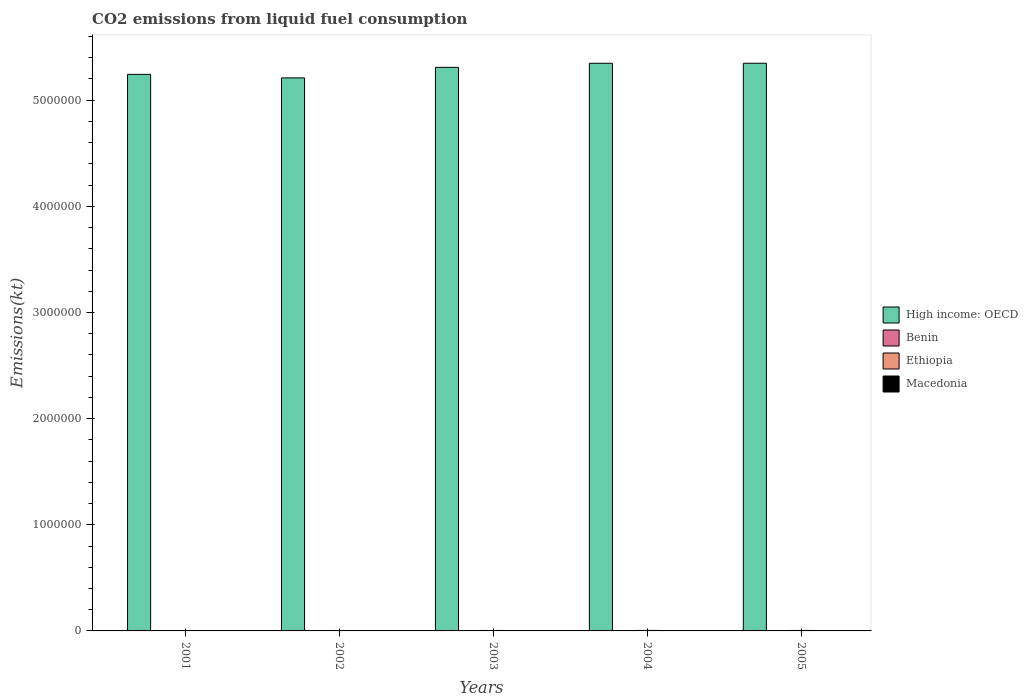How many groups of bars are there?
Provide a succinct answer. 5. Are the number of bars per tick equal to the number of legend labels?
Ensure brevity in your answer.  Yes. How many bars are there on the 3rd tick from the left?
Offer a terse response. 4. What is the label of the 5th group of bars from the left?
Give a very brief answer. 2005. In how many cases, is the number of bars for a given year not equal to the number of legend labels?
Make the answer very short. 0. What is the amount of CO2 emitted in Ethiopia in 2002?
Keep it short and to the point. 4033.7. Across all years, what is the maximum amount of CO2 emitted in Macedonia?
Make the answer very short. 2684.24. Across all years, what is the minimum amount of CO2 emitted in Benin?
Keep it short and to the point. 1690.49. In which year was the amount of CO2 emitted in Benin minimum?
Offer a terse response. 2001. What is the total amount of CO2 emitted in Ethiopia in the graph?
Your answer should be very brief. 2.11e+04. What is the difference between the amount of CO2 emitted in Macedonia in 2003 and that in 2005?
Give a very brief answer. -154.01. What is the difference between the amount of CO2 emitted in High income: OECD in 2005 and the amount of CO2 emitted in Ethiopia in 2003?
Your response must be concise. 5.34e+06. What is the average amount of CO2 emitted in Ethiopia per year?
Offer a terse response. 4227.32. In the year 2004, what is the difference between the amount of CO2 emitted in Benin and amount of CO2 emitted in Macedonia?
Keep it short and to the point. -216.35. In how many years, is the amount of CO2 emitted in High income: OECD greater than 5200000 kt?
Your response must be concise. 5. What is the ratio of the amount of CO2 emitted in Benin in 2002 to that in 2005?
Make the answer very short. 0.86. Is the difference between the amount of CO2 emitted in Benin in 2004 and 2005 greater than the difference between the amount of CO2 emitted in Macedonia in 2004 and 2005?
Your answer should be compact. Yes. What is the difference between the highest and the second highest amount of CO2 emitted in Ethiopia?
Your answer should be compact. 205.35. What is the difference between the highest and the lowest amount of CO2 emitted in Ethiopia?
Offer a very short reply. 726.07. What does the 3rd bar from the left in 2001 represents?
Keep it short and to the point. Ethiopia. What does the 3rd bar from the right in 2005 represents?
Your response must be concise. Benin. Is it the case that in every year, the sum of the amount of CO2 emitted in Ethiopia and amount of CO2 emitted in High income: OECD is greater than the amount of CO2 emitted in Macedonia?
Give a very brief answer. Yes. Are all the bars in the graph horizontal?
Your response must be concise. No. How many years are there in the graph?
Provide a short and direct response. 5. Does the graph contain grids?
Your answer should be very brief. No. How are the legend labels stacked?
Offer a terse response. Vertical. What is the title of the graph?
Keep it short and to the point. CO2 emissions from liquid fuel consumption. What is the label or title of the X-axis?
Make the answer very short. Years. What is the label or title of the Y-axis?
Your answer should be very brief. Emissions(kt). What is the Emissions(kt) in High income: OECD in 2001?
Provide a short and direct response. 5.24e+06. What is the Emissions(kt) in Benin in 2001?
Provide a succinct answer. 1690.49. What is the Emissions(kt) of Ethiopia in 2001?
Provide a succinct answer. 3861.35. What is the Emissions(kt) in Macedonia in 2001?
Give a very brief answer. 2299.21. What is the Emissions(kt) of High income: OECD in 2002?
Offer a terse response. 5.21e+06. What is the Emissions(kt) of Benin in 2002?
Provide a short and direct response. 1954.51. What is the Emissions(kt) of Ethiopia in 2002?
Your answer should be compact. 4033.7. What is the Emissions(kt) in Macedonia in 2002?
Keep it short and to the point. 2563.23. What is the Emissions(kt) in High income: OECD in 2003?
Ensure brevity in your answer.  5.31e+06. What is the Emissions(kt) in Benin in 2003?
Your response must be concise. 2229.54. What is the Emissions(kt) in Ethiopia in 2003?
Provide a succinct answer. 4382.06. What is the Emissions(kt) in Macedonia in 2003?
Ensure brevity in your answer.  2530.23. What is the Emissions(kt) in High income: OECD in 2004?
Your response must be concise. 5.35e+06. What is the Emissions(kt) of Benin in 2004?
Provide a succinct answer. 2383.55. What is the Emissions(kt) of Ethiopia in 2004?
Keep it short and to the point. 4587.42. What is the Emissions(kt) in Macedonia in 2004?
Your answer should be very brief. 2599.9. What is the Emissions(kt) of High income: OECD in 2005?
Your answer should be compact. 5.35e+06. What is the Emissions(kt) of Benin in 2005?
Your response must be concise. 2269.87. What is the Emissions(kt) in Ethiopia in 2005?
Ensure brevity in your answer.  4272.06. What is the Emissions(kt) of Macedonia in 2005?
Keep it short and to the point. 2684.24. Across all years, what is the maximum Emissions(kt) of High income: OECD?
Make the answer very short. 5.35e+06. Across all years, what is the maximum Emissions(kt) in Benin?
Keep it short and to the point. 2383.55. Across all years, what is the maximum Emissions(kt) of Ethiopia?
Your response must be concise. 4587.42. Across all years, what is the maximum Emissions(kt) of Macedonia?
Your response must be concise. 2684.24. Across all years, what is the minimum Emissions(kt) of High income: OECD?
Give a very brief answer. 5.21e+06. Across all years, what is the minimum Emissions(kt) in Benin?
Your answer should be very brief. 1690.49. Across all years, what is the minimum Emissions(kt) of Ethiopia?
Give a very brief answer. 3861.35. Across all years, what is the minimum Emissions(kt) of Macedonia?
Your answer should be very brief. 2299.21. What is the total Emissions(kt) of High income: OECD in the graph?
Ensure brevity in your answer.  2.65e+07. What is the total Emissions(kt) of Benin in the graph?
Your response must be concise. 1.05e+04. What is the total Emissions(kt) in Ethiopia in the graph?
Keep it short and to the point. 2.11e+04. What is the total Emissions(kt) in Macedonia in the graph?
Your answer should be compact. 1.27e+04. What is the difference between the Emissions(kt) of High income: OECD in 2001 and that in 2002?
Your response must be concise. 3.33e+04. What is the difference between the Emissions(kt) of Benin in 2001 and that in 2002?
Keep it short and to the point. -264.02. What is the difference between the Emissions(kt) of Ethiopia in 2001 and that in 2002?
Offer a very short reply. -172.35. What is the difference between the Emissions(kt) in Macedonia in 2001 and that in 2002?
Ensure brevity in your answer.  -264.02. What is the difference between the Emissions(kt) in High income: OECD in 2001 and that in 2003?
Your response must be concise. -6.61e+04. What is the difference between the Emissions(kt) in Benin in 2001 and that in 2003?
Ensure brevity in your answer.  -539.05. What is the difference between the Emissions(kt) of Ethiopia in 2001 and that in 2003?
Provide a short and direct response. -520.71. What is the difference between the Emissions(kt) of Macedonia in 2001 and that in 2003?
Provide a short and direct response. -231.02. What is the difference between the Emissions(kt) of High income: OECD in 2001 and that in 2004?
Make the answer very short. -1.04e+05. What is the difference between the Emissions(kt) in Benin in 2001 and that in 2004?
Offer a very short reply. -693.06. What is the difference between the Emissions(kt) in Ethiopia in 2001 and that in 2004?
Give a very brief answer. -726.07. What is the difference between the Emissions(kt) of Macedonia in 2001 and that in 2004?
Offer a very short reply. -300.69. What is the difference between the Emissions(kt) of High income: OECD in 2001 and that in 2005?
Ensure brevity in your answer.  -1.05e+05. What is the difference between the Emissions(kt) in Benin in 2001 and that in 2005?
Offer a terse response. -579.39. What is the difference between the Emissions(kt) of Ethiopia in 2001 and that in 2005?
Provide a short and direct response. -410.7. What is the difference between the Emissions(kt) in Macedonia in 2001 and that in 2005?
Provide a short and direct response. -385.04. What is the difference between the Emissions(kt) in High income: OECD in 2002 and that in 2003?
Your answer should be compact. -9.93e+04. What is the difference between the Emissions(kt) of Benin in 2002 and that in 2003?
Offer a very short reply. -275.02. What is the difference between the Emissions(kt) of Ethiopia in 2002 and that in 2003?
Offer a terse response. -348.37. What is the difference between the Emissions(kt) of Macedonia in 2002 and that in 2003?
Your answer should be very brief. 33. What is the difference between the Emissions(kt) in High income: OECD in 2002 and that in 2004?
Provide a short and direct response. -1.37e+05. What is the difference between the Emissions(kt) in Benin in 2002 and that in 2004?
Provide a short and direct response. -429.04. What is the difference between the Emissions(kt) in Ethiopia in 2002 and that in 2004?
Offer a terse response. -553.72. What is the difference between the Emissions(kt) in Macedonia in 2002 and that in 2004?
Keep it short and to the point. -36.67. What is the difference between the Emissions(kt) in High income: OECD in 2002 and that in 2005?
Ensure brevity in your answer.  -1.38e+05. What is the difference between the Emissions(kt) of Benin in 2002 and that in 2005?
Provide a short and direct response. -315.36. What is the difference between the Emissions(kt) in Ethiopia in 2002 and that in 2005?
Make the answer very short. -238.35. What is the difference between the Emissions(kt) of Macedonia in 2002 and that in 2005?
Keep it short and to the point. -121.01. What is the difference between the Emissions(kt) of High income: OECD in 2003 and that in 2004?
Provide a short and direct response. -3.81e+04. What is the difference between the Emissions(kt) in Benin in 2003 and that in 2004?
Offer a very short reply. -154.01. What is the difference between the Emissions(kt) of Ethiopia in 2003 and that in 2004?
Your response must be concise. -205.35. What is the difference between the Emissions(kt) of Macedonia in 2003 and that in 2004?
Offer a very short reply. -69.67. What is the difference between the Emissions(kt) in High income: OECD in 2003 and that in 2005?
Offer a very short reply. -3.84e+04. What is the difference between the Emissions(kt) of Benin in 2003 and that in 2005?
Make the answer very short. -40.34. What is the difference between the Emissions(kt) in Ethiopia in 2003 and that in 2005?
Your answer should be compact. 110.01. What is the difference between the Emissions(kt) in Macedonia in 2003 and that in 2005?
Keep it short and to the point. -154.01. What is the difference between the Emissions(kt) in High income: OECD in 2004 and that in 2005?
Provide a succinct answer. -322.7. What is the difference between the Emissions(kt) of Benin in 2004 and that in 2005?
Ensure brevity in your answer.  113.68. What is the difference between the Emissions(kt) in Ethiopia in 2004 and that in 2005?
Keep it short and to the point. 315.36. What is the difference between the Emissions(kt) of Macedonia in 2004 and that in 2005?
Provide a succinct answer. -84.34. What is the difference between the Emissions(kt) of High income: OECD in 2001 and the Emissions(kt) of Benin in 2002?
Your response must be concise. 5.24e+06. What is the difference between the Emissions(kt) of High income: OECD in 2001 and the Emissions(kt) of Ethiopia in 2002?
Keep it short and to the point. 5.24e+06. What is the difference between the Emissions(kt) in High income: OECD in 2001 and the Emissions(kt) in Macedonia in 2002?
Your answer should be very brief. 5.24e+06. What is the difference between the Emissions(kt) in Benin in 2001 and the Emissions(kt) in Ethiopia in 2002?
Your answer should be compact. -2343.21. What is the difference between the Emissions(kt) in Benin in 2001 and the Emissions(kt) in Macedonia in 2002?
Your response must be concise. -872.75. What is the difference between the Emissions(kt) in Ethiopia in 2001 and the Emissions(kt) in Macedonia in 2002?
Give a very brief answer. 1298.12. What is the difference between the Emissions(kt) in High income: OECD in 2001 and the Emissions(kt) in Benin in 2003?
Ensure brevity in your answer.  5.24e+06. What is the difference between the Emissions(kt) of High income: OECD in 2001 and the Emissions(kt) of Ethiopia in 2003?
Give a very brief answer. 5.24e+06. What is the difference between the Emissions(kt) of High income: OECD in 2001 and the Emissions(kt) of Macedonia in 2003?
Offer a terse response. 5.24e+06. What is the difference between the Emissions(kt) in Benin in 2001 and the Emissions(kt) in Ethiopia in 2003?
Offer a very short reply. -2691.58. What is the difference between the Emissions(kt) of Benin in 2001 and the Emissions(kt) of Macedonia in 2003?
Ensure brevity in your answer.  -839.74. What is the difference between the Emissions(kt) in Ethiopia in 2001 and the Emissions(kt) in Macedonia in 2003?
Your answer should be very brief. 1331.12. What is the difference between the Emissions(kt) of High income: OECD in 2001 and the Emissions(kt) of Benin in 2004?
Make the answer very short. 5.24e+06. What is the difference between the Emissions(kt) in High income: OECD in 2001 and the Emissions(kt) in Ethiopia in 2004?
Give a very brief answer. 5.24e+06. What is the difference between the Emissions(kt) of High income: OECD in 2001 and the Emissions(kt) of Macedonia in 2004?
Keep it short and to the point. 5.24e+06. What is the difference between the Emissions(kt) of Benin in 2001 and the Emissions(kt) of Ethiopia in 2004?
Keep it short and to the point. -2896.93. What is the difference between the Emissions(kt) in Benin in 2001 and the Emissions(kt) in Macedonia in 2004?
Your answer should be compact. -909.42. What is the difference between the Emissions(kt) of Ethiopia in 2001 and the Emissions(kt) of Macedonia in 2004?
Ensure brevity in your answer.  1261.45. What is the difference between the Emissions(kt) in High income: OECD in 2001 and the Emissions(kt) in Benin in 2005?
Ensure brevity in your answer.  5.24e+06. What is the difference between the Emissions(kt) of High income: OECD in 2001 and the Emissions(kt) of Ethiopia in 2005?
Offer a terse response. 5.24e+06. What is the difference between the Emissions(kt) of High income: OECD in 2001 and the Emissions(kt) of Macedonia in 2005?
Offer a terse response. 5.24e+06. What is the difference between the Emissions(kt) of Benin in 2001 and the Emissions(kt) of Ethiopia in 2005?
Offer a terse response. -2581.57. What is the difference between the Emissions(kt) of Benin in 2001 and the Emissions(kt) of Macedonia in 2005?
Provide a succinct answer. -993.76. What is the difference between the Emissions(kt) of Ethiopia in 2001 and the Emissions(kt) of Macedonia in 2005?
Make the answer very short. 1177.11. What is the difference between the Emissions(kt) of High income: OECD in 2002 and the Emissions(kt) of Benin in 2003?
Your answer should be compact. 5.21e+06. What is the difference between the Emissions(kt) in High income: OECD in 2002 and the Emissions(kt) in Ethiopia in 2003?
Keep it short and to the point. 5.21e+06. What is the difference between the Emissions(kt) in High income: OECD in 2002 and the Emissions(kt) in Macedonia in 2003?
Keep it short and to the point. 5.21e+06. What is the difference between the Emissions(kt) of Benin in 2002 and the Emissions(kt) of Ethiopia in 2003?
Make the answer very short. -2427.55. What is the difference between the Emissions(kt) in Benin in 2002 and the Emissions(kt) in Macedonia in 2003?
Offer a very short reply. -575.72. What is the difference between the Emissions(kt) in Ethiopia in 2002 and the Emissions(kt) in Macedonia in 2003?
Offer a terse response. 1503.47. What is the difference between the Emissions(kt) of High income: OECD in 2002 and the Emissions(kt) of Benin in 2004?
Make the answer very short. 5.21e+06. What is the difference between the Emissions(kt) of High income: OECD in 2002 and the Emissions(kt) of Ethiopia in 2004?
Make the answer very short. 5.21e+06. What is the difference between the Emissions(kt) in High income: OECD in 2002 and the Emissions(kt) in Macedonia in 2004?
Provide a short and direct response. 5.21e+06. What is the difference between the Emissions(kt) of Benin in 2002 and the Emissions(kt) of Ethiopia in 2004?
Keep it short and to the point. -2632.91. What is the difference between the Emissions(kt) of Benin in 2002 and the Emissions(kt) of Macedonia in 2004?
Provide a succinct answer. -645.39. What is the difference between the Emissions(kt) in Ethiopia in 2002 and the Emissions(kt) in Macedonia in 2004?
Your answer should be very brief. 1433.8. What is the difference between the Emissions(kt) in High income: OECD in 2002 and the Emissions(kt) in Benin in 2005?
Give a very brief answer. 5.21e+06. What is the difference between the Emissions(kt) of High income: OECD in 2002 and the Emissions(kt) of Ethiopia in 2005?
Ensure brevity in your answer.  5.21e+06. What is the difference between the Emissions(kt) of High income: OECD in 2002 and the Emissions(kt) of Macedonia in 2005?
Provide a succinct answer. 5.21e+06. What is the difference between the Emissions(kt) in Benin in 2002 and the Emissions(kt) in Ethiopia in 2005?
Give a very brief answer. -2317.54. What is the difference between the Emissions(kt) of Benin in 2002 and the Emissions(kt) of Macedonia in 2005?
Your response must be concise. -729.73. What is the difference between the Emissions(kt) of Ethiopia in 2002 and the Emissions(kt) of Macedonia in 2005?
Your response must be concise. 1349.46. What is the difference between the Emissions(kt) in High income: OECD in 2003 and the Emissions(kt) in Benin in 2004?
Give a very brief answer. 5.31e+06. What is the difference between the Emissions(kt) in High income: OECD in 2003 and the Emissions(kt) in Ethiopia in 2004?
Make the answer very short. 5.30e+06. What is the difference between the Emissions(kt) of High income: OECD in 2003 and the Emissions(kt) of Macedonia in 2004?
Ensure brevity in your answer.  5.31e+06. What is the difference between the Emissions(kt) of Benin in 2003 and the Emissions(kt) of Ethiopia in 2004?
Give a very brief answer. -2357.88. What is the difference between the Emissions(kt) in Benin in 2003 and the Emissions(kt) in Macedonia in 2004?
Offer a terse response. -370.37. What is the difference between the Emissions(kt) of Ethiopia in 2003 and the Emissions(kt) of Macedonia in 2004?
Your answer should be very brief. 1782.16. What is the difference between the Emissions(kt) of High income: OECD in 2003 and the Emissions(kt) of Benin in 2005?
Ensure brevity in your answer.  5.31e+06. What is the difference between the Emissions(kt) in High income: OECD in 2003 and the Emissions(kt) in Ethiopia in 2005?
Offer a terse response. 5.31e+06. What is the difference between the Emissions(kt) of High income: OECD in 2003 and the Emissions(kt) of Macedonia in 2005?
Your answer should be compact. 5.31e+06. What is the difference between the Emissions(kt) of Benin in 2003 and the Emissions(kt) of Ethiopia in 2005?
Your answer should be very brief. -2042.52. What is the difference between the Emissions(kt) of Benin in 2003 and the Emissions(kt) of Macedonia in 2005?
Provide a succinct answer. -454.71. What is the difference between the Emissions(kt) of Ethiopia in 2003 and the Emissions(kt) of Macedonia in 2005?
Your answer should be very brief. 1697.82. What is the difference between the Emissions(kt) in High income: OECD in 2004 and the Emissions(kt) in Benin in 2005?
Ensure brevity in your answer.  5.35e+06. What is the difference between the Emissions(kt) of High income: OECD in 2004 and the Emissions(kt) of Ethiopia in 2005?
Offer a terse response. 5.34e+06. What is the difference between the Emissions(kt) of High income: OECD in 2004 and the Emissions(kt) of Macedonia in 2005?
Your response must be concise. 5.34e+06. What is the difference between the Emissions(kt) in Benin in 2004 and the Emissions(kt) in Ethiopia in 2005?
Keep it short and to the point. -1888.51. What is the difference between the Emissions(kt) of Benin in 2004 and the Emissions(kt) of Macedonia in 2005?
Your response must be concise. -300.69. What is the difference between the Emissions(kt) of Ethiopia in 2004 and the Emissions(kt) of Macedonia in 2005?
Make the answer very short. 1903.17. What is the average Emissions(kt) in High income: OECD per year?
Provide a succinct answer. 5.29e+06. What is the average Emissions(kt) of Benin per year?
Keep it short and to the point. 2105.59. What is the average Emissions(kt) in Ethiopia per year?
Provide a short and direct response. 4227.32. What is the average Emissions(kt) in Macedonia per year?
Provide a short and direct response. 2535.36. In the year 2001, what is the difference between the Emissions(kt) in High income: OECD and Emissions(kt) in Benin?
Offer a terse response. 5.24e+06. In the year 2001, what is the difference between the Emissions(kt) of High income: OECD and Emissions(kt) of Ethiopia?
Offer a terse response. 5.24e+06. In the year 2001, what is the difference between the Emissions(kt) in High income: OECD and Emissions(kt) in Macedonia?
Give a very brief answer. 5.24e+06. In the year 2001, what is the difference between the Emissions(kt) in Benin and Emissions(kt) in Ethiopia?
Keep it short and to the point. -2170.86. In the year 2001, what is the difference between the Emissions(kt) in Benin and Emissions(kt) in Macedonia?
Offer a terse response. -608.72. In the year 2001, what is the difference between the Emissions(kt) of Ethiopia and Emissions(kt) of Macedonia?
Make the answer very short. 1562.14. In the year 2002, what is the difference between the Emissions(kt) of High income: OECD and Emissions(kt) of Benin?
Ensure brevity in your answer.  5.21e+06. In the year 2002, what is the difference between the Emissions(kt) of High income: OECD and Emissions(kt) of Ethiopia?
Offer a terse response. 5.21e+06. In the year 2002, what is the difference between the Emissions(kt) of High income: OECD and Emissions(kt) of Macedonia?
Offer a very short reply. 5.21e+06. In the year 2002, what is the difference between the Emissions(kt) of Benin and Emissions(kt) of Ethiopia?
Make the answer very short. -2079.19. In the year 2002, what is the difference between the Emissions(kt) of Benin and Emissions(kt) of Macedonia?
Give a very brief answer. -608.72. In the year 2002, what is the difference between the Emissions(kt) in Ethiopia and Emissions(kt) in Macedonia?
Offer a terse response. 1470.47. In the year 2003, what is the difference between the Emissions(kt) of High income: OECD and Emissions(kt) of Benin?
Your answer should be very brief. 5.31e+06. In the year 2003, what is the difference between the Emissions(kt) in High income: OECD and Emissions(kt) in Ethiopia?
Provide a succinct answer. 5.31e+06. In the year 2003, what is the difference between the Emissions(kt) of High income: OECD and Emissions(kt) of Macedonia?
Keep it short and to the point. 5.31e+06. In the year 2003, what is the difference between the Emissions(kt) in Benin and Emissions(kt) in Ethiopia?
Provide a succinct answer. -2152.53. In the year 2003, what is the difference between the Emissions(kt) of Benin and Emissions(kt) of Macedonia?
Keep it short and to the point. -300.69. In the year 2003, what is the difference between the Emissions(kt) of Ethiopia and Emissions(kt) of Macedonia?
Give a very brief answer. 1851.84. In the year 2004, what is the difference between the Emissions(kt) in High income: OECD and Emissions(kt) in Benin?
Make the answer very short. 5.35e+06. In the year 2004, what is the difference between the Emissions(kt) in High income: OECD and Emissions(kt) in Ethiopia?
Offer a terse response. 5.34e+06. In the year 2004, what is the difference between the Emissions(kt) in High income: OECD and Emissions(kt) in Macedonia?
Your answer should be very brief. 5.35e+06. In the year 2004, what is the difference between the Emissions(kt) of Benin and Emissions(kt) of Ethiopia?
Offer a very short reply. -2203.87. In the year 2004, what is the difference between the Emissions(kt) of Benin and Emissions(kt) of Macedonia?
Provide a short and direct response. -216.35. In the year 2004, what is the difference between the Emissions(kt) of Ethiopia and Emissions(kt) of Macedonia?
Offer a very short reply. 1987.51. In the year 2005, what is the difference between the Emissions(kt) of High income: OECD and Emissions(kt) of Benin?
Make the answer very short. 5.35e+06. In the year 2005, what is the difference between the Emissions(kt) in High income: OECD and Emissions(kt) in Ethiopia?
Provide a succinct answer. 5.34e+06. In the year 2005, what is the difference between the Emissions(kt) of High income: OECD and Emissions(kt) of Macedonia?
Provide a short and direct response. 5.35e+06. In the year 2005, what is the difference between the Emissions(kt) of Benin and Emissions(kt) of Ethiopia?
Your answer should be very brief. -2002.18. In the year 2005, what is the difference between the Emissions(kt) of Benin and Emissions(kt) of Macedonia?
Offer a very short reply. -414.37. In the year 2005, what is the difference between the Emissions(kt) in Ethiopia and Emissions(kt) in Macedonia?
Offer a terse response. 1587.81. What is the ratio of the Emissions(kt) in High income: OECD in 2001 to that in 2002?
Make the answer very short. 1.01. What is the ratio of the Emissions(kt) of Benin in 2001 to that in 2002?
Offer a very short reply. 0.86. What is the ratio of the Emissions(kt) of Ethiopia in 2001 to that in 2002?
Your response must be concise. 0.96. What is the ratio of the Emissions(kt) in Macedonia in 2001 to that in 2002?
Ensure brevity in your answer.  0.9. What is the ratio of the Emissions(kt) of High income: OECD in 2001 to that in 2003?
Provide a succinct answer. 0.99. What is the ratio of the Emissions(kt) in Benin in 2001 to that in 2003?
Give a very brief answer. 0.76. What is the ratio of the Emissions(kt) of Ethiopia in 2001 to that in 2003?
Give a very brief answer. 0.88. What is the ratio of the Emissions(kt) of Macedonia in 2001 to that in 2003?
Your response must be concise. 0.91. What is the ratio of the Emissions(kt) of High income: OECD in 2001 to that in 2004?
Make the answer very short. 0.98. What is the ratio of the Emissions(kt) in Benin in 2001 to that in 2004?
Your answer should be very brief. 0.71. What is the ratio of the Emissions(kt) in Ethiopia in 2001 to that in 2004?
Provide a succinct answer. 0.84. What is the ratio of the Emissions(kt) of Macedonia in 2001 to that in 2004?
Offer a terse response. 0.88. What is the ratio of the Emissions(kt) in High income: OECD in 2001 to that in 2005?
Your answer should be very brief. 0.98. What is the ratio of the Emissions(kt) of Benin in 2001 to that in 2005?
Your answer should be very brief. 0.74. What is the ratio of the Emissions(kt) in Ethiopia in 2001 to that in 2005?
Offer a terse response. 0.9. What is the ratio of the Emissions(kt) in Macedonia in 2001 to that in 2005?
Ensure brevity in your answer.  0.86. What is the ratio of the Emissions(kt) in High income: OECD in 2002 to that in 2003?
Offer a very short reply. 0.98. What is the ratio of the Emissions(kt) of Benin in 2002 to that in 2003?
Provide a short and direct response. 0.88. What is the ratio of the Emissions(kt) of Ethiopia in 2002 to that in 2003?
Your response must be concise. 0.92. What is the ratio of the Emissions(kt) in Macedonia in 2002 to that in 2003?
Provide a succinct answer. 1.01. What is the ratio of the Emissions(kt) in High income: OECD in 2002 to that in 2004?
Give a very brief answer. 0.97. What is the ratio of the Emissions(kt) of Benin in 2002 to that in 2004?
Ensure brevity in your answer.  0.82. What is the ratio of the Emissions(kt) of Ethiopia in 2002 to that in 2004?
Provide a succinct answer. 0.88. What is the ratio of the Emissions(kt) of Macedonia in 2002 to that in 2004?
Provide a short and direct response. 0.99. What is the ratio of the Emissions(kt) of High income: OECD in 2002 to that in 2005?
Your response must be concise. 0.97. What is the ratio of the Emissions(kt) of Benin in 2002 to that in 2005?
Provide a short and direct response. 0.86. What is the ratio of the Emissions(kt) in Ethiopia in 2002 to that in 2005?
Provide a succinct answer. 0.94. What is the ratio of the Emissions(kt) of Macedonia in 2002 to that in 2005?
Make the answer very short. 0.95. What is the ratio of the Emissions(kt) in Benin in 2003 to that in 2004?
Your answer should be very brief. 0.94. What is the ratio of the Emissions(kt) of Ethiopia in 2003 to that in 2004?
Keep it short and to the point. 0.96. What is the ratio of the Emissions(kt) in Macedonia in 2003 to that in 2004?
Your answer should be compact. 0.97. What is the ratio of the Emissions(kt) in High income: OECD in 2003 to that in 2005?
Ensure brevity in your answer.  0.99. What is the ratio of the Emissions(kt) in Benin in 2003 to that in 2005?
Offer a very short reply. 0.98. What is the ratio of the Emissions(kt) of Ethiopia in 2003 to that in 2005?
Your answer should be compact. 1.03. What is the ratio of the Emissions(kt) of Macedonia in 2003 to that in 2005?
Provide a succinct answer. 0.94. What is the ratio of the Emissions(kt) in Benin in 2004 to that in 2005?
Provide a short and direct response. 1.05. What is the ratio of the Emissions(kt) of Ethiopia in 2004 to that in 2005?
Provide a succinct answer. 1.07. What is the ratio of the Emissions(kt) of Macedonia in 2004 to that in 2005?
Your answer should be very brief. 0.97. What is the difference between the highest and the second highest Emissions(kt) in High income: OECD?
Make the answer very short. 322.7. What is the difference between the highest and the second highest Emissions(kt) of Benin?
Your response must be concise. 113.68. What is the difference between the highest and the second highest Emissions(kt) in Ethiopia?
Provide a short and direct response. 205.35. What is the difference between the highest and the second highest Emissions(kt) of Macedonia?
Provide a short and direct response. 84.34. What is the difference between the highest and the lowest Emissions(kt) of High income: OECD?
Provide a short and direct response. 1.38e+05. What is the difference between the highest and the lowest Emissions(kt) in Benin?
Keep it short and to the point. 693.06. What is the difference between the highest and the lowest Emissions(kt) in Ethiopia?
Your answer should be compact. 726.07. What is the difference between the highest and the lowest Emissions(kt) in Macedonia?
Provide a succinct answer. 385.04. 